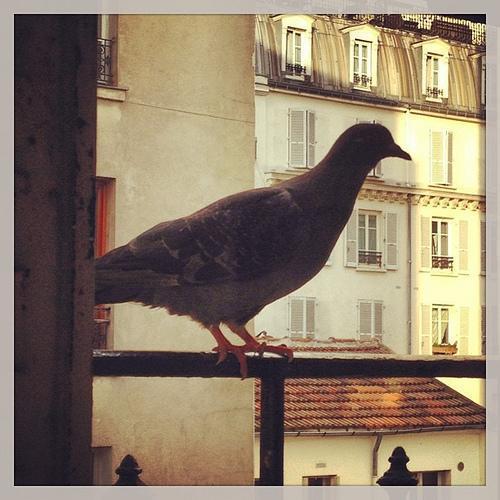How many birds are shown?
Give a very brief answer. 1. 